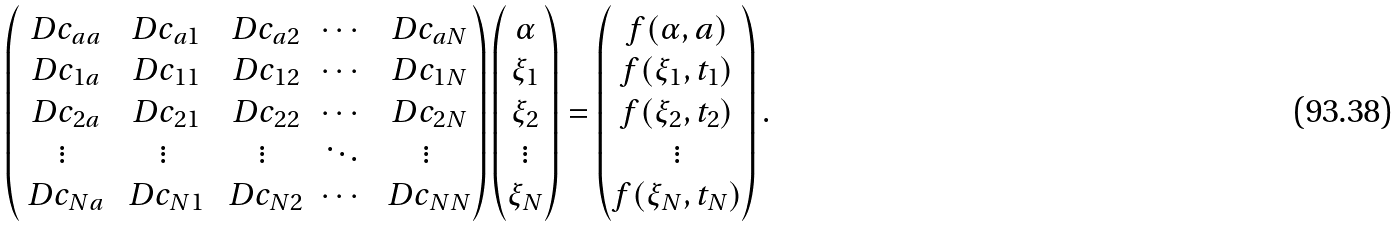Convert formula to latex. <formula><loc_0><loc_0><loc_500><loc_500>\begin{pmatrix} \ D c _ { a a } & \ D c _ { a 1 } & \ D c _ { a 2 } & \cdots & \ D c _ { a N } \\ \ D c _ { 1 a } & \ D c _ { 1 1 } & \ D c _ { 1 2 } & \cdots & \ D c _ { 1 N } \\ \ D c _ { 2 a } & \ D c _ { 2 1 } & \ D c _ { 2 2 } & \cdots & \ D c _ { 2 N } \\ \vdots & \vdots & \vdots & \ddots & \vdots \\ \ D c _ { N a } & \ D c _ { N 1 } & \ D c _ { N 2 } & \cdots & \ D c _ { N N } \end{pmatrix} \begin{pmatrix} \alpha \\ \xi _ { 1 } \\ \xi _ { 2 } \\ \vdots \\ \xi _ { N } \end{pmatrix} = \begin{pmatrix} f ( \alpha , a ) \\ f ( \xi _ { 1 } , t _ { 1 } ) \\ f ( \xi _ { 2 } , t _ { 2 } ) \\ \vdots \\ f ( \xi _ { N } , t _ { N } ) \end{pmatrix} .</formula> 